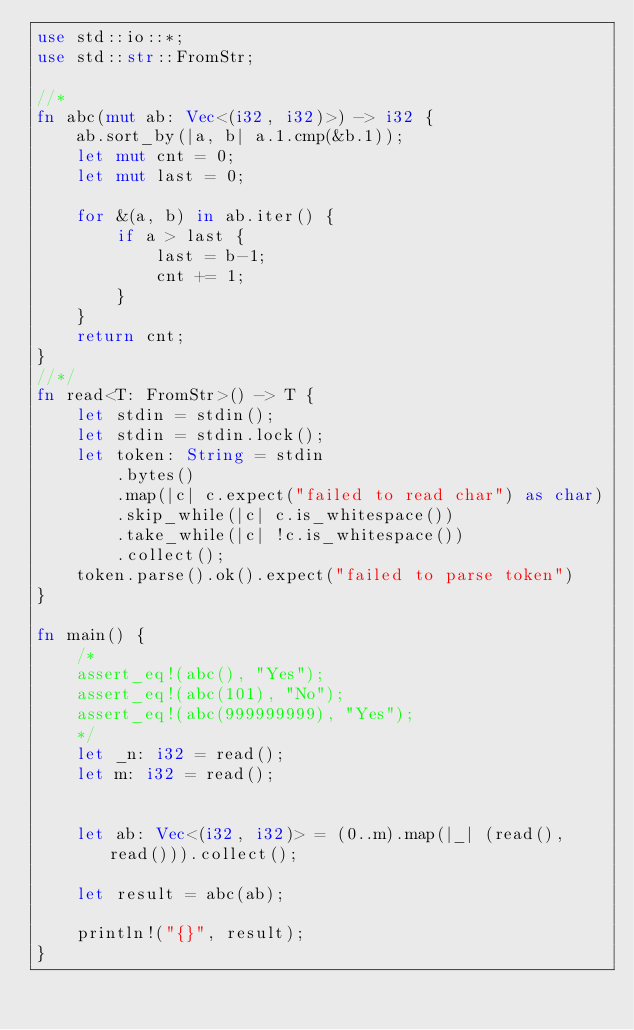<code> <loc_0><loc_0><loc_500><loc_500><_Rust_>use std::io::*;
use std::str::FromStr;

//*
fn abc(mut ab: Vec<(i32, i32)>) -> i32 {
    ab.sort_by(|a, b| a.1.cmp(&b.1));
    let mut cnt = 0;
    let mut last = 0;

    for &(a, b) in ab.iter() {
        if a > last {
            last = b-1;
            cnt += 1;
        }
    }
    return cnt;
}
//*/
fn read<T: FromStr>() -> T {
    let stdin = stdin();
    let stdin = stdin.lock();
    let token: String = stdin
        .bytes()
        .map(|c| c.expect("failed to read char") as char) 
        .skip_while(|c| c.is_whitespace())
        .take_while(|c| !c.is_whitespace())
        .collect();
    token.parse().ok().expect("failed to parse token")
}

fn main() {
    /*
    assert_eq!(abc(), "Yes");
    assert_eq!(abc(101), "No");
    assert_eq!(abc(999999999), "Yes");
    */
    let _n: i32 = read();
    let m: i32 = read();


    let ab: Vec<(i32, i32)> = (0..m).map(|_| (read(), read())).collect();

    let result = abc(ab);
    
    println!("{}", result);
}


</code> 